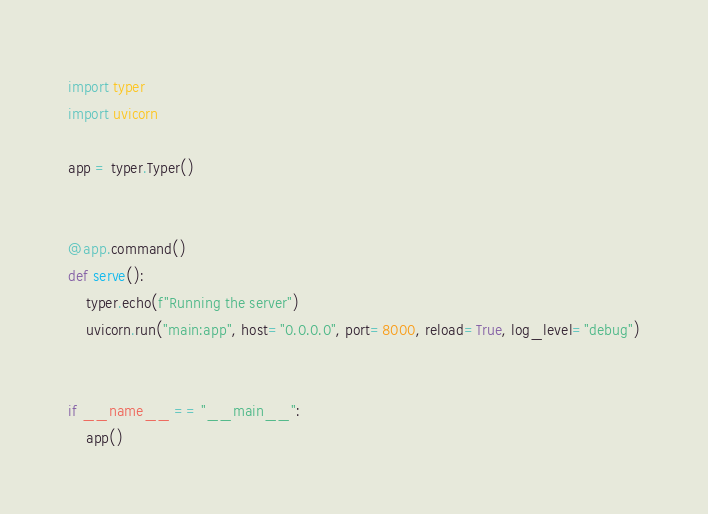Convert code to text. <code><loc_0><loc_0><loc_500><loc_500><_Python_>import typer
import uvicorn

app = typer.Typer()


@app.command()
def serve():
    typer.echo(f"Running the server")
    uvicorn.run("main:app", host="0.0.0.0", port=8000, reload=True, log_level="debug")


if __name__ == "__main__":
    app()
</code> 